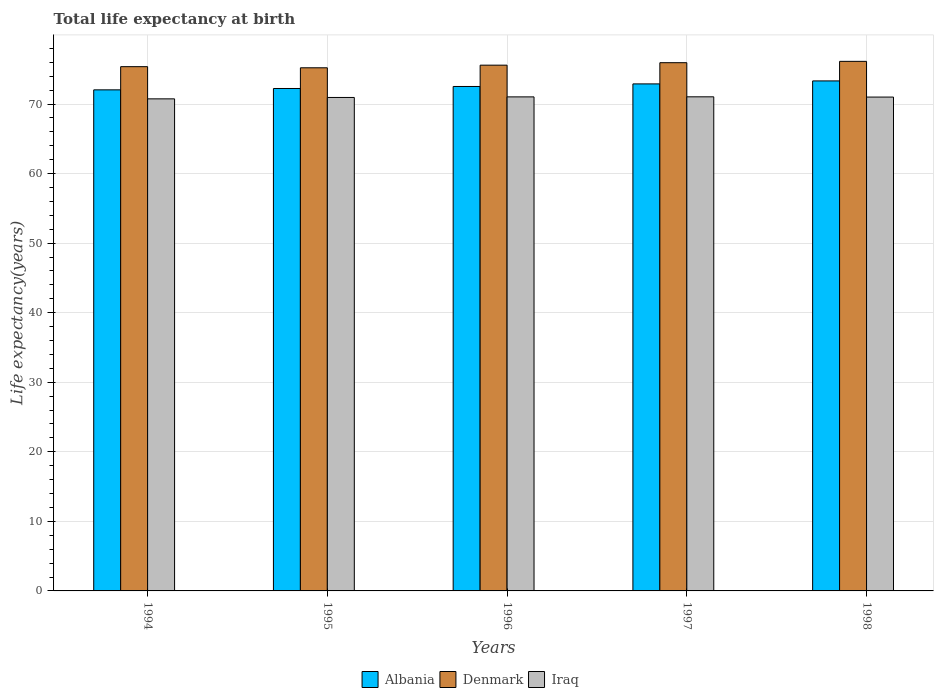How many different coloured bars are there?
Give a very brief answer. 3. Are the number of bars on each tick of the X-axis equal?
Your response must be concise. Yes. In how many cases, is the number of bars for a given year not equal to the number of legend labels?
Your response must be concise. 0. What is the life expectancy at birth in in Albania in 1997?
Provide a succinct answer. 72.9. Across all years, what is the maximum life expectancy at birth in in Albania?
Your answer should be very brief. 73.33. Across all years, what is the minimum life expectancy at birth in in Denmark?
Provide a succinct answer. 75.21. In which year was the life expectancy at birth in in Iraq maximum?
Provide a succinct answer. 1997. What is the total life expectancy at birth in in Denmark in the graph?
Make the answer very short. 378.26. What is the difference between the life expectancy at birth in in Denmark in 1995 and that in 1996?
Provide a succinct answer. -0.38. What is the difference between the life expectancy at birth in in Iraq in 1998 and the life expectancy at birth in in Albania in 1997?
Keep it short and to the point. -1.9. What is the average life expectancy at birth in in Denmark per year?
Give a very brief answer. 75.65. In the year 1996, what is the difference between the life expectancy at birth in in Denmark and life expectancy at birth in in Albania?
Make the answer very short. 3.06. What is the ratio of the life expectancy at birth in in Denmark in 1994 to that in 1997?
Make the answer very short. 0.99. Is the life expectancy at birth in in Iraq in 1994 less than that in 1997?
Provide a succinct answer. Yes. Is the difference between the life expectancy at birth in in Denmark in 1995 and 1998 greater than the difference between the life expectancy at birth in in Albania in 1995 and 1998?
Give a very brief answer. Yes. What is the difference between the highest and the second highest life expectancy at birth in in Iraq?
Offer a very short reply. 0.01. What is the difference between the highest and the lowest life expectancy at birth in in Denmark?
Make the answer very short. 0.93. In how many years, is the life expectancy at birth in in Albania greater than the average life expectancy at birth in in Albania taken over all years?
Your answer should be very brief. 2. Is the sum of the life expectancy at birth in in Denmark in 1996 and 1998 greater than the maximum life expectancy at birth in in Iraq across all years?
Give a very brief answer. Yes. What does the 3rd bar from the left in 1994 represents?
Offer a very short reply. Iraq. What does the 1st bar from the right in 1994 represents?
Ensure brevity in your answer.  Iraq. Is it the case that in every year, the sum of the life expectancy at birth in in Iraq and life expectancy at birth in in Denmark is greater than the life expectancy at birth in in Albania?
Provide a short and direct response. Yes. Does the graph contain grids?
Your answer should be very brief. Yes. How many legend labels are there?
Offer a terse response. 3. What is the title of the graph?
Offer a very short reply. Total life expectancy at birth. What is the label or title of the X-axis?
Provide a short and direct response. Years. What is the label or title of the Y-axis?
Give a very brief answer. Life expectancy(years). What is the Life expectancy(years) of Albania in 1994?
Your answer should be compact. 72.04. What is the Life expectancy(years) in Denmark in 1994?
Provide a short and direct response. 75.38. What is the Life expectancy(years) in Iraq in 1994?
Your response must be concise. 70.75. What is the Life expectancy(years) of Albania in 1995?
Provide a succinct answer. 72.24. What is the Life expectancy(years) of Denmark in 1995?
Give a very brief answer. 75.21. What is the Life expectancy(years) of Iraq in 1995?
Provide a succinct answer. 70.95. What is the Life expectancy(years) of Albania in 1996?
Offer a terse response. 72.53. What is the Life expectancy(years) of Denmark in 1996?
Ensure brevity in your answer.  75.59. What is the Life expectancy(years) in Iraq in 1996?
Your response must be concise. 71.03. What is the Life expectancy(years) in Albania in 1997?
Provide a succinct answer. 72.9. What is the Life expectancy(years) of Denmark in 1997?
Give a very brief answer. 75.95. What is the Life expectancy(years) of Iraq in 1997?
Offer a very short reply. 71.04. What is the Life expectancy(years) in Albania in 1998?
Offer a very short reply. 73.33. What is the Life expectancy(years) of Denmark in 1998?
Offer a very short reply. 76.14. What is the Life expectancy(years) of Iraq in 1998?
Offer a very short reply. 71. Across all years, what is the maximum Life expectancy(years) in Albania?
Ensure brevity in your answer.  73.33. Across all years, what is the maximum Life expectancy(years) of Denmark?
Provide a succinct answer. 76.14. Across all years, what is the maximum Life expectancy(years) of Iraq?
Offer a very short reply. 71.04. Across all years, what is the minimum Life expectancy(years) of Albania?
Give a very brief answer. 72.04. Across all years, what is the minimum Life expectancy(years) in Denmark?
Your answer should be very brief. 75.21. Across all years, what is the minimum Life expectancy(years) of Iraq?
Give a very brief answer. 70.75. What is the total Life expectancy(years) of Albania in the graph?
Offer a very short reply. 363.03. What is the total Life expectancy(years) in Denmark in the graph?
Keep it short and to the point. 378.26. What is the total Life expectancy(years) of Iraq in the graph?
Give a very brief answer. 354.77. What is the difference between the Life expectancy(years) in Albania in 1994 and that in 1995?
Make the answer very short. -0.19. What is the difference between the Life expectancy(years) in Denmark in 1994 and that in 1995?
Keep it short and to the point. 0.16. What is the difference between the Life expectancy(years) in Iraq in 1994 and that in 1995?
Ensure brevity in your answer.  -0.2. What is the difference between the Life expectancy(years) of Albania in 1994 and that in 1996?
Provide a short and direct response. -0.49. What is the difference between the Life expectancy(years) of Denmark in 1994 and that in 1996?
Provide a succinct answer. -0.22. What is the difference between the Life expectancy(years) in Iraq in 1994 and that in 1996?
Provide a short and direct response. -0.28. What is the difference between the Life expectancy(years) in Albania in 1994 and that in 1997?
Your answer should be compact. -0.86. What is the difference between the Life expectancy(years) of Denmark in 1994 and that in 1997?
Your answer should be very brief. -0.57. What is the difference between the Life expectancy(years) in Iraq in 1994 and that in 1997?
Provide a short and direct response. -0.29. What is the difference between the Life expectancy(years) in Albania in 1994 and that in 1998?
Offer a very short reply. -1.28. What is the difference between the Life expectancy(years) in Denmark in 1994 and that in 1998?
Provide a short and direct response. -0.76. What is the difference between the Life expectancy(years) in Iraq in 1994 and that in 1998?
Make the answer very short. -0.25. What is the difference between the Life expectancy(years) of Albania in 1995 and that in 1996?
Ensure brevity in your answer.  -0.29. What is the difference between the Life expectancy(years) in Denmark in 1995 and that in 1996?
Your answer should be compact. -0.38. What is the difference between the Life expectancy(years) in Iraq in 1995 and that in 1996?
Your answer should be compact. -0.08. What is the difference between the Life expectancy(years) of Albania in 1995 and that in 1997?
Provide a short and direct response. -0.66. What is the difference between the Life expectancy(years) in Denmark in 1995 and that in 1997?
Offer a very short reply. -0.73. What is the difference between the Life expectancy(years) of Iraq in 1995 and that in 1997?
Your response must be concise. -0.09. What is the difference between the Life expectancy(years) of Albania in 1995 and that in 1998?
Your answer should be very brief. -1.09. What is the difference between the Life expectancy(years) in Denmark in 1995 and that in 1998?
Make the answer very short. -0.93. What is the difference between the Life expectancy(years) of Iraq in 1995 and that in 1998?
Give a very brief answer. -0.06. What is the difference between the Life expectancy(years) in Albania in 1996 and that in 1997?
Offer a terse response. -0.37. What is the difference between the Life expectancy(years) of Denmark in 1996 and that in 1997?
Provide a succinct answer. -0.35. What is the difference between the Life expectancy(years) in Iraq in 1996 and that in 1997?
Provide a short and direct response. -0.01. What is the difference between the Life expectancy(years) of Albania in 1996 and that in 1998?
Offer a very short reply. -0.8. What is the difference between the Life expectancy(years) in Denmark in 1996 and that in 1998?
Keep it short and to the point. -0.55. What is the difference between the Life expectancy(years) of Iraq in 1996 and that in 1998?
Ensure brevity in your answer.  0.03. What is the difference between the Life expectancy(years) of Albania in 1997 and that in 1998?
Make the answer very short. -0.43. What is the difference between the Life expectancy(years) of Denmark in 1997 and that in 1998?
Provide a short and direct response. -0.19. What is the difference between the Life expectancy(years) of Iraq in 1997 and that in 1998?
Provide a succinct answer. 0.04. What is the difference between the Life expectancy(years) of Albania in 1994 and the Life expectancy(years) of Denmark in 1995?
Ensure brevity in your answer.  -3.17. What is the difference between the Life expectancy(years) of Albania in 1994 and the Life expectancy(years) of Iraq in 1995?
Offer a terse response. 1.1. What is the difference between the Life expectancy(years) of Denmark in 1994 and the Life expectancy(years) of Iraq in 1995?
Make the answer very short. 4.43. What is the difference between the Life expectancy(years) in Albania in 1994 and the Life expectancy(years) in Denmark in 1996?
Your response must be concise. -3.55. What is the difference between the Life expectancy(years) of Albania in 1994 and the Life expectancy(years) of Iraq in 1996?
Your response must be concise. 1.01. What is the difference between the Life expectancy(years) in Denmark in 1994 and the Life expectancy(years) in Iraq in 1996?
Your answer should be very brief. 4.34. What is the difference between the Life expectancy(years) in Albania in 1994 and the Life expectancy(years) in Denmark in 1997?
Give a very brief answer. -3.9. What is the difference between the Life expectancy(years) of Albania in 1994 and the Life expectancy(years) of Iraq in 1997?
Your answer should be very brief. 1. What is the difference between the Life expectancy(years) of Denmark in 1994 and the Life expectancy(years) of Iraq in 1997?
Your answer should be compact. 4.33. What is the difference between the Life expectancy(years) of Albania in 1994 and the Life expectancy(years) of Denmark in 1998?
Keep it short and to the point. -4.1. What is the difference between the Life expectancy(years) in Albania in 1994 and the Life expectancy(years) in Iraq in 1998?
Your response must be concise. 1.04. What is the difference between the Life expectancy(years) in Denmark in 1994 and the Life expectancy(years) in Iraq in 1998?
Give a very brief answer. 4.37. What is the difference between the Life expectancy(years) of Albania in 1995 and the Life expectancy(years) of Denmark in 1996?
Your response must be concise. -3.36. What is the difference between the Life expectancy(years) of Albania in 1995 and the Life expectancy(years) of Iraq in 1996?
Provide a succinct answer. 1.2. What is the difference between the Life expectancy(years) of Denmark in 1995 and the Life expectancy(years) of Iraq in 1996?
Keep it short and to the point. 4.18. What is the difference between the Life expectancy(years) of Albania in 1995 and the Life expectancy(years) of Denmark in 1997?
Offer a terse response. -3.71. What is the difference between the Life expectancy(years) of Albania in 1995 and the Life expectancy(years) of Iraq in 1997?
Provide a succinct answer. 1.2. What is the difference between the Life expectancy(years) in Denmark in 1995 and the Life expectancy(years) in Iraq in 1997?
Keep it short and to the point. 4.17. What is the difference between the Life expectancy(years) in Albania in 1995 and the Life expectancy(years) in Denmark in 1998?
Ensure brevity in your answer.  -3.9. What is the difference between the Life expectancy(years) of Albania in 1995 and the Life expectancy(years) of Iraq in 1998?
Make the answer very short. 1.23. What is the difference between the Life expectancy(years) in Denmark in 1995 and the Life expectancy(years) in Iraq in 1998?
Offer a terse response. 4.21. What is the difference between the Life expectancy(years) of Albania in 1996 and the Life expectancy(years) of Denmark in 1997?
Provide a short and direct response. -3.42. What is the difference between the Life expectancy(years) of Albania in 1996 and the Life expectancy(years) of Iraq in 1997?
Your response must be concise. 1.49. What is the difference between the Life expectancy(years) in Denmark in 1996 and the Life expectancy(years) in Iraq in 1997?
Your response must be concise. 4.55. What is the difference between the Life expectancy(years) of Albania in 1996 and the Life expectancy(years) of Denmark in 1998?
Give a very brief answer. -3.61. What is the difference between the Life expectancy(years) in Albania in 1996 and the Life expectancy(years) in Iraq in 1998?
Offer a terse response. 1.52. What is the difference between the Life expectancy(years) of Denmark in 1996 and the Life expectancy(years) of Iraq in 1998?
Provide a short and direct response. 4.59. What is the difference between the Life expectancy(years) of Albania in 1997 and the Life expectancy(years) of Denmark in 1998?
Provide a short and direct response. -3.24. What is the difference between the Life expectancy(years) of Albania in 1997 and the Life expectancy(years) of Iraq in 1998?
Your answer should be very brief. 1.9. What is the difference between the Life expectancy(years) of Denmark in 1997 and the Life expectancy(years) of Iraq in 1998?
Provide a short and direct response. 4.94. What is the average Life expectancy(years) of Albania per year?
Provide a succinct answer. 72.61. What is the average Life expectancy(years) in Denmark per year?
Give a very brief answer. 75.65. What is the average Life expectancy(years) in Iraq per year?
Provide a succinct answer. 70.95. In the year 1994, what is the difference between the Life expectancy(years) of Albania and Life expectancy(years) of Denmark?
Provide a short and direct response. -3.33. In the year 1994, what is the difference between the Life expectancy(years) of Albania and Life expectancy(years) of Iraq?
Offer a very short reply. 1.29. In the year 1994, what is the difference between the Life expectancy(years) in Denmark and Life expectancy(years) in Iraq?
Your response must be concise. 4.63. In the year 1995, what is the difference between the Life expectancy(years) in Albania and Life expectancy(years) in Denmark?
Your response must be concise. -2.98. In the year 1995, what is the difference between the Life expectancy(years) in Albania and Life expectancy(years) in Iraq?
Keep it short and to the point. 1.29. In the year 1995, what is the difference between the Life expectancy(years) of Denmark and Life expectancy(years) of Iraq?
Provide a short and direct response. 4.27. In the year 1996, what is the difference between the Life expectancy(years) of Albania and Life expectancy(years) of Denmark?
Offer a very short reply. -3.06. In the year 1996, what is the difference between the Life expectancy(years) of Albania and Life expectancy(years) of Iraq?
Offer a very short reply. 1.5. In the year 1996, what is the difference between the Life expectancy(years) in Denmark and Life expectancy(years) in Iraq?
Ensure brevity in your answer.  4.56. In the year 1997, what is the difference between the Life expectancy(years) in Albania and Life expectancy(years) in Denmark?
Your answer should be compact. -3.05. In the year 1997, what is the difference between the Life expectancy(years) in Albania and Life expectancy(years) in Iraq?
Make the answer very short. 1.86. In the year 1997, what is the difference between the Life expectancy(years) in Denmark and Life expectancy(years) in Iraq?
Keep it short and to the point. 4.9. In the year 1998, what is the difference between the Life expectancy(years) of Albania and Life expectancy(years) of Denmark?
Offer a very short reply. -2.81. In the year 1998, what is the difference between the Life expectancy(years) in Albania and Life expectancy(years) in Iraq?
Your answer should be compact. 2.32. In the year 1998, what is the difference between the Life expectancy(years) of Denmark and Life expectancy(years) of Iraq?
Provide a short and direct response. 5.14. What is the ratio of the Life expectancy(years) of Albania in 1994 to that in 1995?
Your answer should be very brief. 1. What is the ratio of the Life expectancy(years) of Iraq in 1994 to that in 1995?
Your answer should be compact. 1. What is the ratio of the Life expectancy(years) in Albania in 1994 to that in 1996?
Offer a terse response. 0.99. What is the ratio of the Life expectancy(years) in Denmark in 1994 to that in 1996?
Make the answer very short. 1. What is the ratio of the Life expectancy(years) of Albania in 1994 to that in 1997?
Your answer should be compact. 0.99. What is the ratio of the Life expectancy(years) of Denmark in 1994 to that in 1997?
Make the answer very short. 0.99. What is the ratio of the Life expectancy(years) in Iraq in 1994 to that in 1997?
Make the answer very short. 1. What is the ratio of the Life expectancy(years) of Albania in 1994 to that in 1998?
Provide a succinct answer. 0.98. What is the ratio of the Life expectancy(years) in Albania in 1995 to that in 1997?
Offer a terse response. 0.99. What is the ratio of the Life expectancy(years) of Albania in 1995 to that in 1998?
Offer a terse response. 0.99. What is the ratio of the Life expectancy(years) of Albania in 1996 to that in 1997?
Make the answer very short. 0.99. What is the ratio of the Life expectancy(years) in Denmark in 1996 to that in 1997?
Offer a terse response. 1. What is the ratio of the Life expectancy(years) in Albania in 1996 to that in 1998?
Offer a terse response. 0.99. What is the ratio of the Life expectancy(years) in Denmark in 1996 to that in 1998?
Provide a succinct answer. 0.99. What is the ratio of the Life expectancy(years) in Iraq in 1996 to that in 1998?
Your answer should be very brief. 1. What is the ratio of the Life expectancy(years) of Albania in 1997 to that in 1998?
Your answer should be very brief. 0.99. What is the ratio of the Life expectancy(years) of Denmark in 1997 to that in 1998?
Your response must be concise. 1. What is the ratio of the Life expectancy(years) in Iraq in 1997 to that in 1998?
Provide a short and direct response. 1. What is the difference between the highest and the second highest Life expectancy(years) of Albania?
Offer a very short reply. 0.43. What is the difference between the highest and the second highest Life expectancy(years) in Denmark?
Keep it short and to the point. 0.19. What is the difference between the highest and the second highest Life expectancy(years) of Iraq?
Give a very brief answer. 0.01. What is the difference between the highest and the lowest Life expectancy(years) of Albania?
Offer a very short reply. 1.28. What is the difference between the highest and the lowest Life expectancy(years) of Denmark?
Your answer should be compact. 0.93. What is the difference between the highest and the lowest Life expectancy(years) of Iraq?
Make the answer very short. 0.29. 